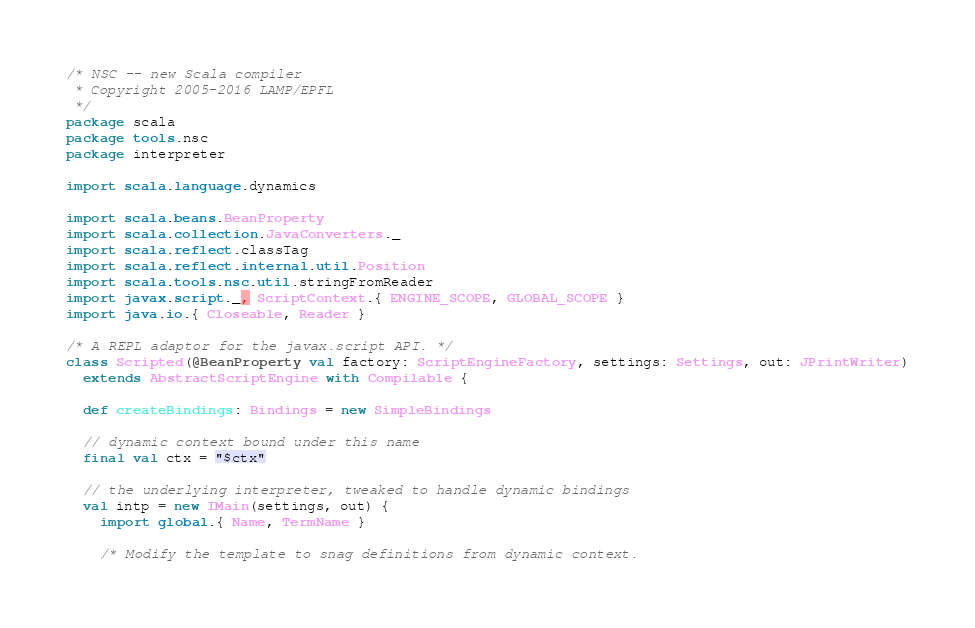<code> <loc_0><loc_0><loc_500><loc_500><_Scala_>/* NSC -- new Scala compiler
 * Copyright 2005-2016 LAMP/EPFL
 */
package scala
package tools.nsc
package interpreter

import scala.language.dynamics

import scala.beans.BeanProperty
import scala.collection.JavaConverters._
import scala.reflect.classTag
import scala.reflect.internal.util.Position
import scala.tools.nsc.util.stringFromReader
import javax.script._, ScriptContext.{ ENGINE_SCOPE, GLOBAL_SCOPE }
import java.io.{ Closeable, Reader }

/* A REPL adaptor for the javax.script API. */
class Scripted(@BeanProperty val factory: ScriptEngineFactory, settings: Settings, out: JPrintWriter)
  extends AbstractScriptEngine with Compilable {

  def createBindings: Bindings = new SimpleBindings

  // dynamic context bound under this name
  final val ctx = "$ctx"

  // the underlying interpreter, tweaked to handle dynamic bindings
  val intp = new IMain(settings, out) {
    import global.{ Name, TermName }

    /* Modify the template to snag definitions from dynamic context.</code> 